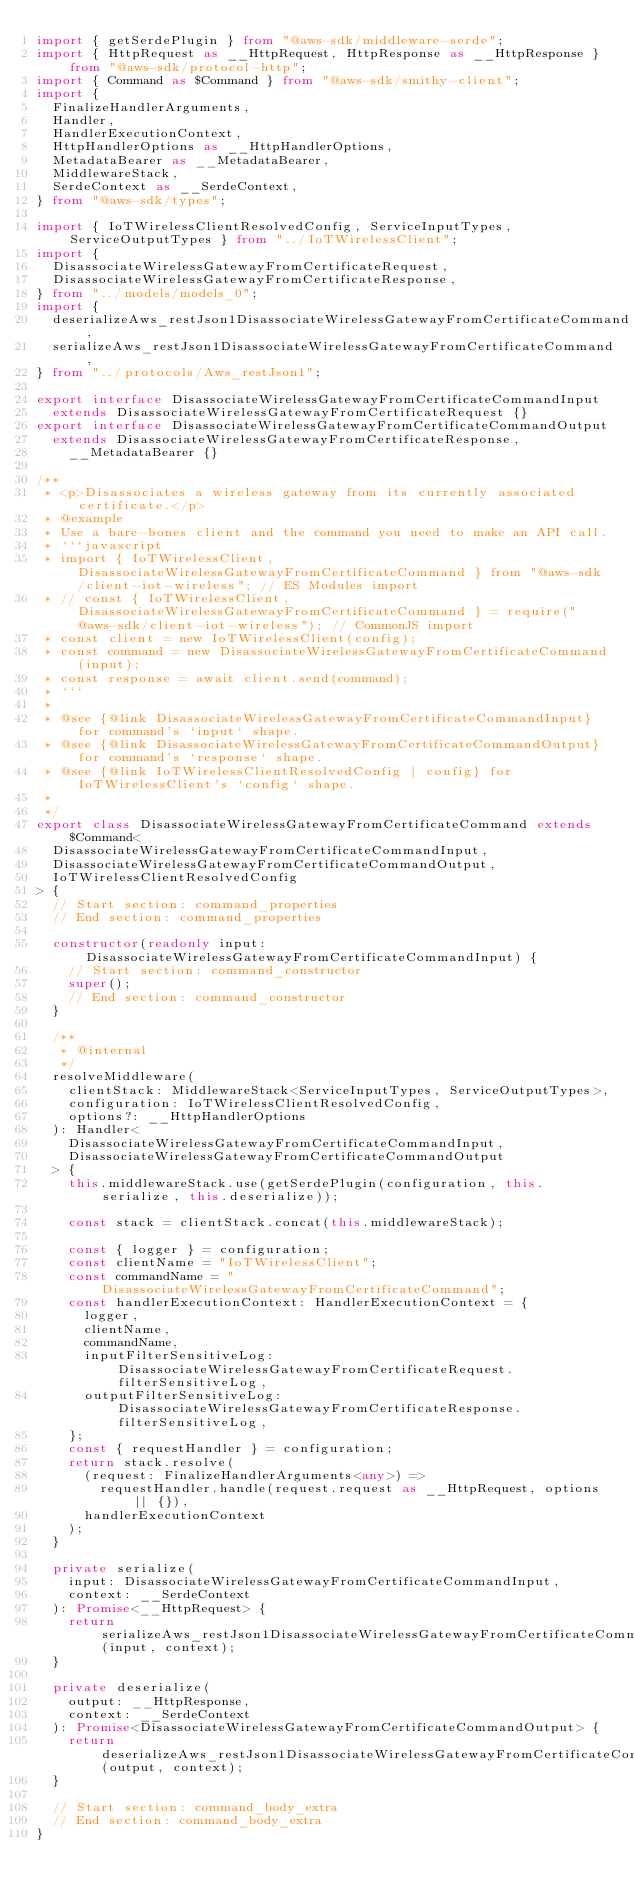Convert code to text. <code><loc_0><loc_0><loc_500><loc_500><_TypeScript_>import { getSerdePlugin } from "@aws-sdk/middleware-serde";
import { HttpRequest as __HttpRequest, HttpResponse as __HttpResponse } from "@aws-sdk/protocol-http";
import { Command as $Command } from "@aws-sdk/smithy-client";
import {
  FinalizeHandlerArguments,
  Handler,
  HandlerExecutionContext,
  HttpHandlerOptions as __HttpHandlerOptions,
  MetadataBearer as __MetadataBearer,
  MiddlewareStack,
  SerdeContext as __SerdeContext,
} from "@aws-sdk/types";

import { IoTWirelessClientResolvedConfig, ServiceInputTypes, ServiceOutputTypes } from "../IoTWirelessClient";
import {
  DisassociateWirelessGatewayFromCertificateRequest,
  DisassociateWirelessGatewayFromCertificateResponse,
} from "../models/models_0";
import {
  deserializeAws_restJson1DisassociateWirelessGatewayFromCertificateCommand,
  serializeAws_restJson1DisassociateWirelessGatewayFromCertificateCommand,
} from "../protocols/Aws_restJson1";

export interface DisassociateWirelessGatewayFromCertificateCommandInput
  extends DisassociateWirelessGatewayFromCertificateRequest {}
export interface DisassociateWirelessGatewayFromCertificateCommandOutput
  extends DisassociateWirelessGatewayFromCertificateResponse,
    __MetadataBearer {}

/**
 * <p>Disassociates a wireless gateway from its currently associated certificate.</p>
 * @example
 * Use a bare-bones client and the command you need to make an API call.
 * ```javascript
 * import { IoTWirelessClient, DisassociateWirelessGatewayFromCertificateCommand } from "@aws-sdk/client-iot-wireless"; // ES Modules import
 * // const { IoTWirelessClient, DisassociateWirelessGatewayFromCertificateCommand } = require("@aws-sdk/client-iot-wireless"); // CommonJS import
 * const client = new IoTWirelessClient(config);
 * const command = new DisassociateWirelessGatewayFromCertificateCommand(input);
 * const response = await client.send(command);
 * ```
 *
 * @see {@link DisassociateWirelessGatewayFromCertificateCommandInput} for command's `input` shape.
 * @see {@link DisassociateWirelessGatewayFromCertificateCommandOutput} for command's `response` shape.
 * @see {@link IoTWirelessClientResolvedConfig | config} for IoTWirelessClient's `config` shape.
 *
 */
export class DisassociateWirelessGatewayFromCertificateCommand extends $Command<
  DisassociateWirelessGatewayFromCertificateCommandInput,
  DisassociateWirelessGatewayFromCertificateCommandOutput,
  IoTWirelessClientResolvedConfig
> {
  // Start section: command_properties
  // End section: command_properties

  constructor(readonly input: DisassociateWirelessGatewayFromCertificateCommandInput) {
    // Start section: command_constructor
    super();
    // End section: command_constructor
  }

  /**
   * @internal
   */
  resolveMiddleware(
    clientStack: MiddlewareStack<ServiceInputTypes, ServiceOutputTypes>,
    configuration: IoTWirelessClientResolvedConfig,
    options?: __HttpHandlerOptions
  ): Handler<
    DisassociateWirelessGatewayFromCertificateCommandInput,
    DisassociateWirelessGatewayFromCertificateCommandOutput
  > {
    this.middlewareStack.use(getSerdePlugin(configuration, this.serialize, this.deserialize));

    const stack = clientStack.concat(this.middlewareStack);

    const { logger } = configuration;
    const clientName = "IoTWirelessClient";
    const commandName = "DisassociateWirelessGatewayFromCertificateCommand";
    const handlerExecutionContext: HandlerExecutionContext = {
      logger,
      clientName,
      commandName,
      inputFilterSensitiveLog: DisassociateWirelessGatewayFromCertificateRequest.filterSensitiveLog,
      outputFilterSensitiveLog: DisassociateWirelessGatewayFromCertificateResponse.filterSensitiveLog,
    };
    const { requestHandler } = configuration;
    return stack.resolve(
      (request: FinalizeHandlerArguments<any>) =>
        requestHandler.handle(request.request as __HttpRequest, options || {}),
      handlerExecutionContext
    );
  }

  private serialize(
    input: DisassociateWirelessGatewayFromCertificateCommandInput,
    context: __SerdeContext
  ): Promise<__HttpRequest> {
    return serializeAws_restJson1DisassociateWirelessGatewayFromCertificateCommand(input, context);
  }

  private deserialize(
    output: __HttpResponse,
    context: __SerdeContext
  ): Promise<DisassociateWirelessGatewayFromCertificateCommandOutput> {
    return deserializeAws_restJson1DisassociateWirelessGatewayFromCertificateCommand(output, context);
  }

  // Start section: command_body_extra
  // End section: command_body_extra
}
</code> 